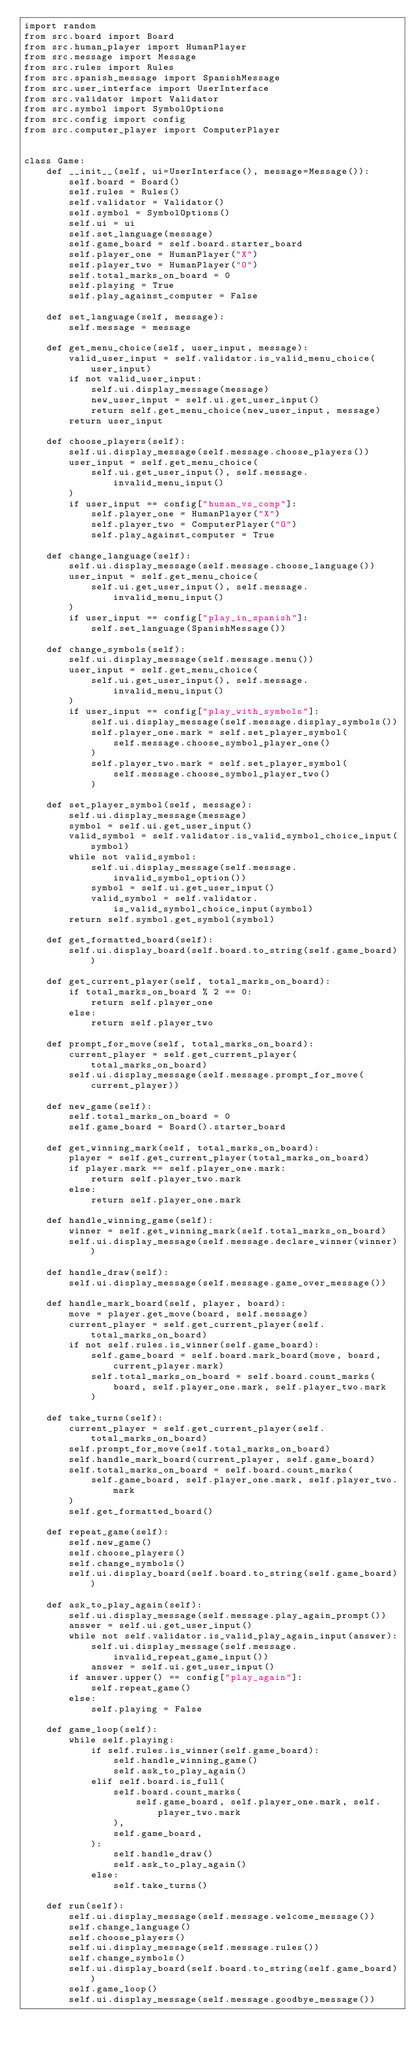<code> <loc_0><loc_0><loc_500><loc_500><_Python_>import random
from src.board import Board
from src.human_player import HumanPlayer
from src.message import Message
from src.rules import Rules
from src.spanish_message import SpanishMessage
from src.user_interface import UserInterface
from src.validator import Validator
from src.symbol import SymbolOptions
from src.config import config
from src.computer_player import ComputerPlayer


class Game:
    def __init__(self, ui=UserInterface(), message=Message()):
        self.board = Board()
        self.rules = Rules()
        self.validator = Validator()
        self.symbol = SymbolOptions()
        self.ui = ui
        self.set_language(message)
        self.game_board = self.board.starter_board
        self.player_one = HumanPlayer("X")
        self.player_two = HumanPlayer("O")
        self.total_marks_on_board = 0
        self.playing = True
        self.play_against_computer = False

    def set_language(self, message):
        self.message = message

    def get_menu_choice(self, user_input, message):
        valid_user_input = self.validator.is_valid_menu_choice(user_input)
        if not valid_user_input:
            self.ui.display_message(message)
            new_user_input = self.ui.get_user_input()
            return self.get_menu_choice(new_user_input, message)
        return user_input

    def choose_players(self):
        self.ui.display_message(self.message.choose_players())
        user_input = self.get_menu_choice(
            self.ui.get_user_input(), self.message.invalid_menu_input()
        )
        if user_input == config["human_vs_comp"]:
            self.player_one = HumanPlayer("X")
            self.player_two = ComputerPlayer("O")
            self.play_against_computer = True

    def change_language(self):
        self.ui.display_message(self.message.choose_language())
        user_input = self.get_menu_choice(
            self.ui.get_user_input(), self.message.invalid_menu_input()
        )
        if user_input == config["play_in_spanish"]:
            self.set_language(SpanishMessage())

    def change_symbols(self):
        self.ui.display_message(self.message.menu())
        user_input = self.get_menu_choice(
            self.ui.get_user_input(), self.message.invalid_menu_input()
        )
        if user_input == config["play_with_symbols"]:
            self.ui.display_message(self.message.display_symbols())
            self.player_one.mark = self.set_player_symbol(
                self.message.choose_symbol_player_one()
            )
            self.player_two.mark = self.set_player_symbol(
                self.message.choose_symbol_player_two()
            )

    def set_player_symbol(self, message):
        self.ui.display_message(message)
        symbol = self.ui.get_user_input()
        valid_symbol = self.validator.is_valid_symbol_choice_input(symbol)
        while not valid_symbol:
            self.ui.display_message(self.message.invalid_symbol_option())
            symbol = self.ui.get_user_input()
            valid_symbol = self.validator.is_valid_symbol_choice_input(symbol)
        return self.symbol.get_symbol(symbol)

    def get_formatted_board(self):
        self.ui.display_board(self.board.to_string(self.game_board))

    def get_current_player(self, total_marks_on_board):
        if total_marks_on_board % 2 == 0:
            return self.player_one
        else:
            return self.player_two

    def prompt_for_move(self, total_marks_on_board):
        current_player = self.get_current_player(total_marks_on_board)
        self.ui.display_message(self.message.prompt_for_move(current_player))

    def new_game(self):
        self.total_marks_on_board = 0
        self.game_board = Board().starter_board

    def get_winning_mark(self, total_marks_on_board):
        player = self.get_current_player(total_marks_on_board)
        if player.mark == self.player_one.mark:
            return self.player_two.mark
        else:
            return self.player_one.mark

    def handle_winning_game(self):
        winner = self.get_winning_mark(self.total_marks_on_board)
        self.ui.display_message(self.message.declare_winner(winner))

    def handle_draw(self):
        self.ui.display_message(self.message.game_over_message())

    def handle_mark_board(self, player, board):
        move = player.get_move(board, self.message)
        current_player = self.get_current_player(self.total_marks_on_board)
        if not self.rules.is_winner(self.game_board):
            self.game_board = self.board.mark_board(move, board, current_player.mark)
            self.total_marks_on_board = self.board.count_marks(
                board, self.player_one.mark, self.player_two.mark
            )

    def take_turns(self):
        current_player = self.get_current_player(self.total_marks_on_board)
        self.prompt_for_move(self.total_marks_on_board)
        self.handle_mark_board(current_player, self.game_board)
        self.total_marks_on_board = self.board.count_marks(
            self.game_board, self.player_one.mark, self.player_two.mark
        )
        self.get_formatted_board()

    def repeat_game(self):
        self.new_game()
        self.choose_players()
        self.change_symbols()
        self.ui.display_board(self.board.to_string(self.game_board))

    def ask_to_play_again(self):
        self.ui.display_message(self.message.play_again_prompt())
        answer = self.ui.get_user_input()
        while not self.validator.is_valid_play_again_input(answer):
            self.ui.display_message(self.message.invalid_repeat_game_input())
            answer = self.ui.get_user_input()
        if answer.upper() == config["play_again"]:
            self.repeat_game()
        else:
            self.playing = False

    def game_loop(self):
        while self.playing:
            if self.rules.is_winner(self.game_board):
                self.handle_winning_game()
                self.ask_to_play_again()
            elif self.board.is_full(
                self.board.count_marks(
                    self.game_board, self.player_one.mark, self.player_two.mark
                ),
                self.game_board,
            ):
                self.handle_draw()
                self.ask_to_play_again()
            else:
                self.take_turns()

    def run(self):
        self.ui.display_message(self.message.welcome_message())
        self.change_language()
        self.choose_players()
        self.ui.display_message(self.message.rules())
        self.change_symbols()
        self.ui.display_board(self.board.to_string(self.game_board))
        self.game_loop()
        self.ui.display_message(self.message.goodbye_message())
</code> 